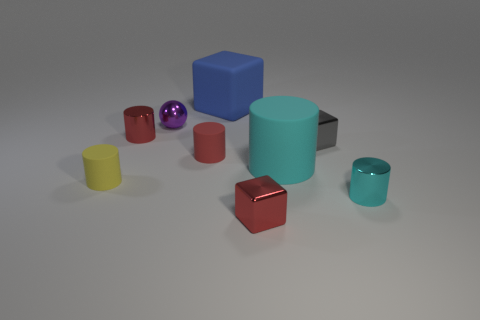Subtract all gray balls. How many cyan cylinders are left? 2 Subtract all matte cubes. How many cubes are left? 2 Subtract all red cylinders. How many cylinders are left? 3 Add 1 cyan metal things. How many objects exist? 10 Subtract 1 cylinders. How many cylinders are left? 4 Subtract all cylinders. How many objects are left? 4 Add 5 tiny gray shiny spheres. How many tiny gray shiny spheres exist? 5 Subtract 0 yellow spheres. How many objects are left? 9 Subtract all brown cylinders. Subtract all cyan blocks. How many cylinders are left? 5 Subtract all big gray matte cubes. Subtract all blue things. How many objects are left? 8 